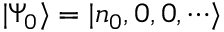Convert formula to latex. <formula><loc_0><loc_0><loc_500><loc_500>| \Psi _ { 0 } \rangle = | n _ { 0 } , 0 , 0 , \cdots \rangle</formula> 